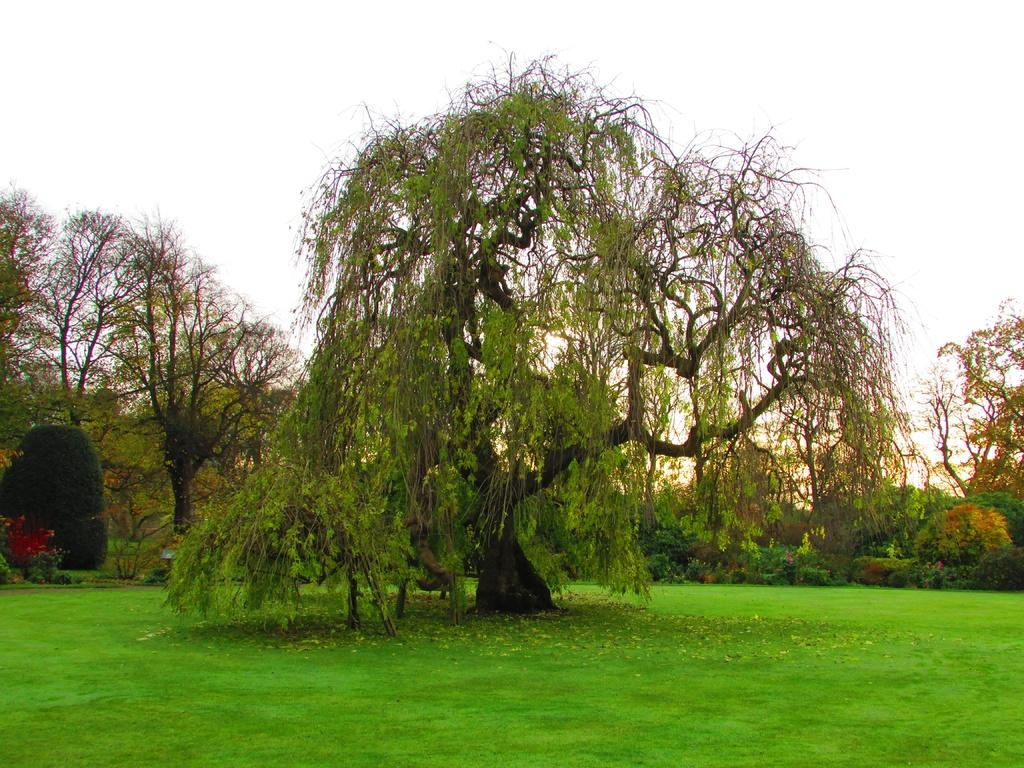What type of vegetation can be seen in the image? There is grass, trees, and plants in the image. What part of the natural environment is visible in the image? The sky is visible in the image. What grade does the finger receive on the card in the image? There is no finger or card present in the image, so this question cannot be answered. 